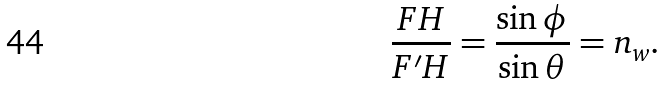<formula> <loc_0><loc_0><loc_500><loc_500>\frac { F H } { F ^ { \prime } H } = \frac { \sin \phi } { \sin \theta } = n _ { w } .</formula> 